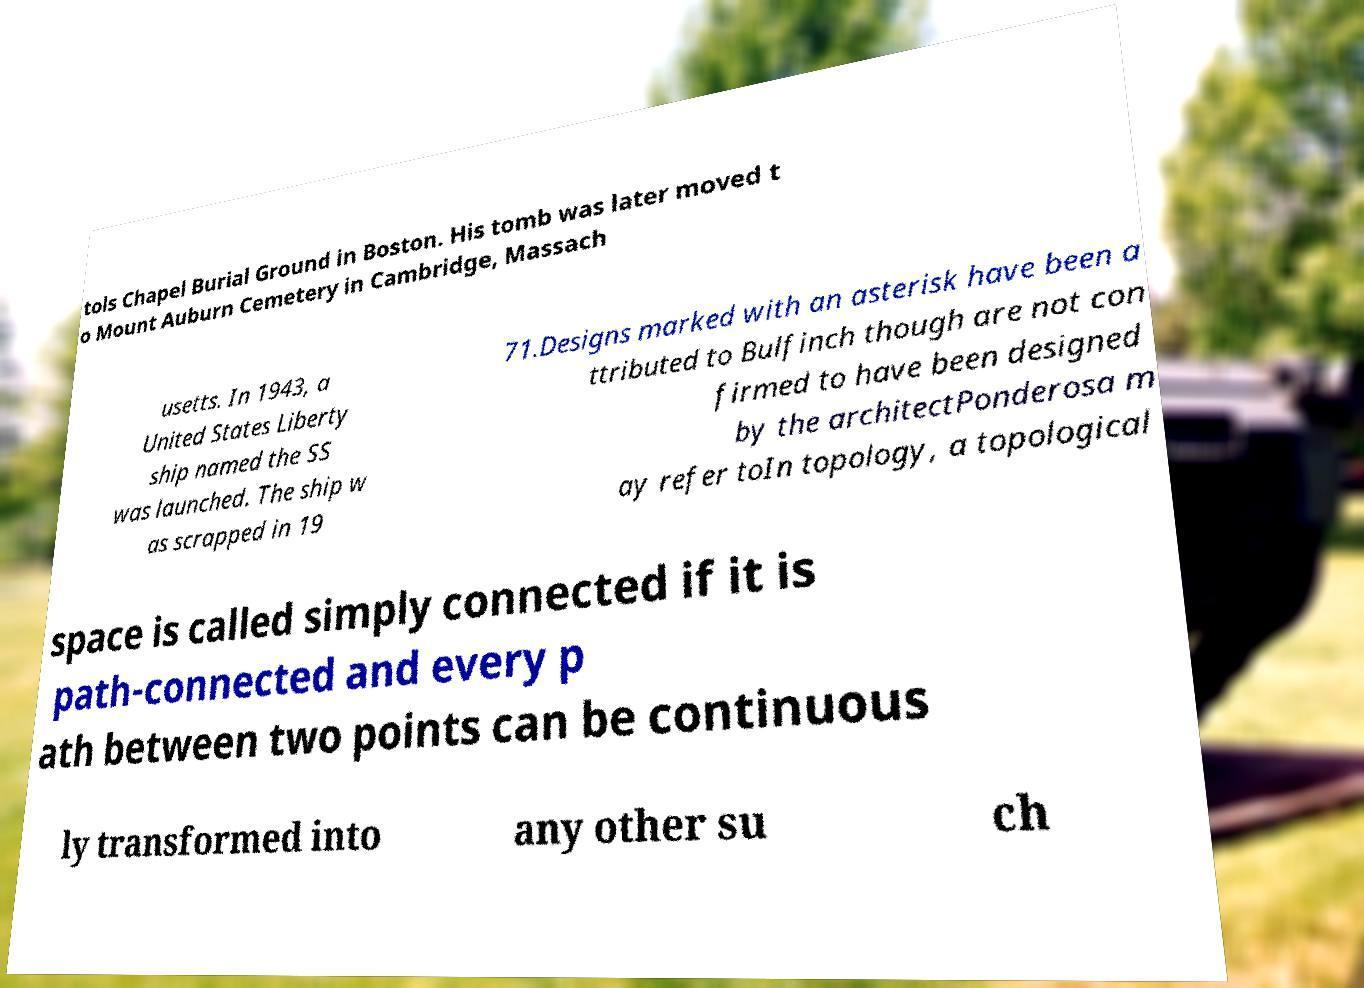Can you accurately transcribe the text from the provided image for me? tols Chapel Burial Ground in Boston. His tomb was later moved t o Mount Auburn Cemetery in Cambridge, Massach usetts. In 1943, a United States Liberty ship named the SS was launched. The ship w as scrapped in 19 71.Designs marked with an asterisk have been a ttributed to Bulfinch though are not con firmed to have been designed by the architectPonderosa m ay refer toIn topology, a topological space is called simply connected if it is path-connected and every p ath between two points can be continuous ly transformed into any other su ch 